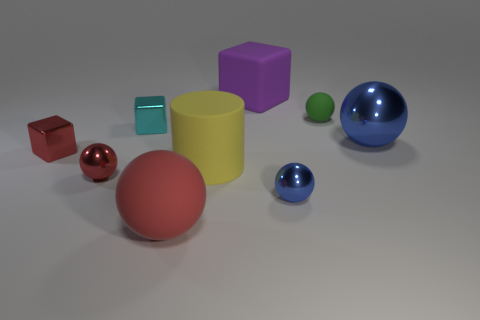Subtract all small red spheres. How many spheres are left? 4 Subtract all purple blocks. How many blocks are left? 2 Add 1 tiny green objects. How many objects exist? 10 Subtract all cyan cubes. How many red spheres are left? 2 Subtract all cylinders. How many objects are left? 8 Subtract 1 blocks. How many blocks are left? 2 Subtract all green cylinders. Subtract all purple blocks. How many cylinders are left? 1 Subtract all rubber cylinders. Subtract all large yellow shiny cubes. How many objects are left? 8 Add 6 large blue spheres. How many large blue spheres are left? 7 Add 3 red spheres. How many red spheres exist? 5 